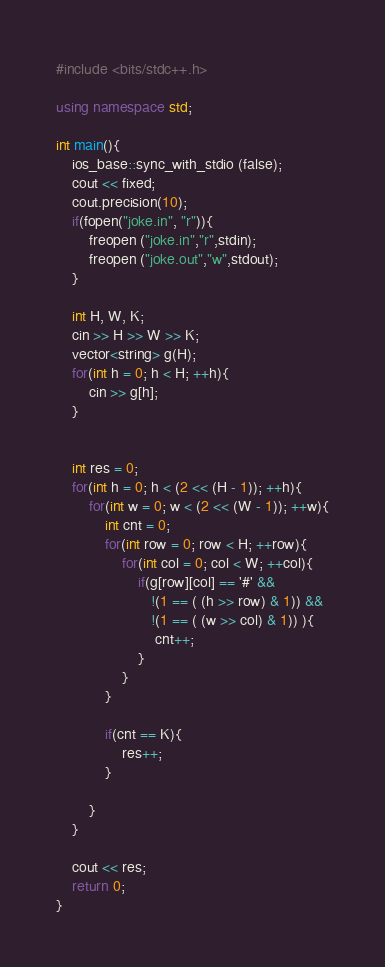<code> <loc_0><loc_0><loc_500><loc_500><_C++_>#include <bits/stdc++.h>

using namespace std;

int main(){
	ios_base::sync_with_stdio (false);
	cout << fixed;
	cout.precision(10);
	if(fopen("joke.in", "r")){
		freopen ("joke.in","r",stdin);
		freopen ("joke.out","w",stdout);
	}

	int H, W, K;
	cin >> H >> W >> K;
	vector<string> g(H);
	for(int h = 0; h < H; ++h){
		cin >> g[h];
	}


	int res = 0;
	for(int h = 0; h < (2 << (H - 1)); ++h){
		for(int w = 0; w < (2 << (W - 1)); ++w){
			int cnt = 0;
			for(int row = 0; row < H; ++row){
				for(int col = 0; col < W; ++col){
					if(g[row][col] == '#' &&
					   !(1 == ( (h >> row) & 1)) &&
					   !(1 == ( (w >> col) & 1)) ){
						cnt++;
					}
				}
			}

			if(cnt == K){
				res++;
			}

		}
	}

	cout << res;
    return 0;
}
</code> 